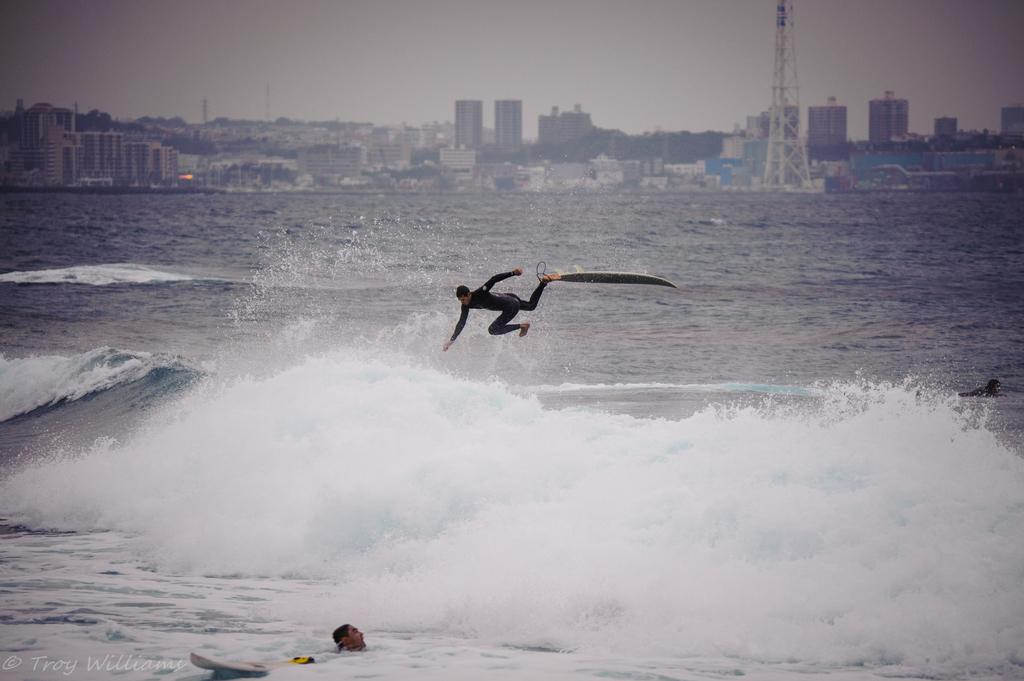What is the main subject in the center of the image? There is a person in the water in the center of the image. What activity is happening in the background of the image? There is a person para surfing on water in the background. What type of natural environment is visible in the background? There is an ocean visible in the background. What type of structures can be seen in the background? There are buildings and a tower in the background. How many mice are playing in the sleet in the image? There are no mice or sleet present in the image. 